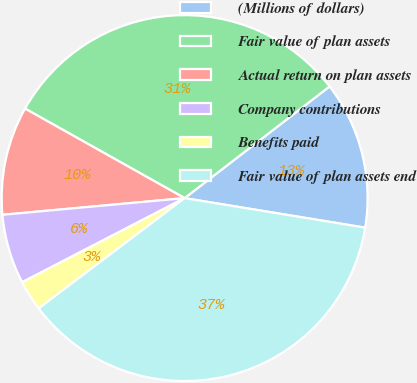Convert chart to OTSL. <chart><loc_0><loc_0><loc_500><loc_500><pie_chart><fcel>(Millions of dollars)<fcel>Fair value of plan assets<fcel>Actual return on plan assets<fcel>Company contributions<fcel>Benefits paid<fcel>Fair value of plan assets end<nl><fcel>13.03%<fcel>31.42%<fcel>9.59%<fcel>6.15%<fcel>2.7%<fcel>37.12%<nl></chart> 